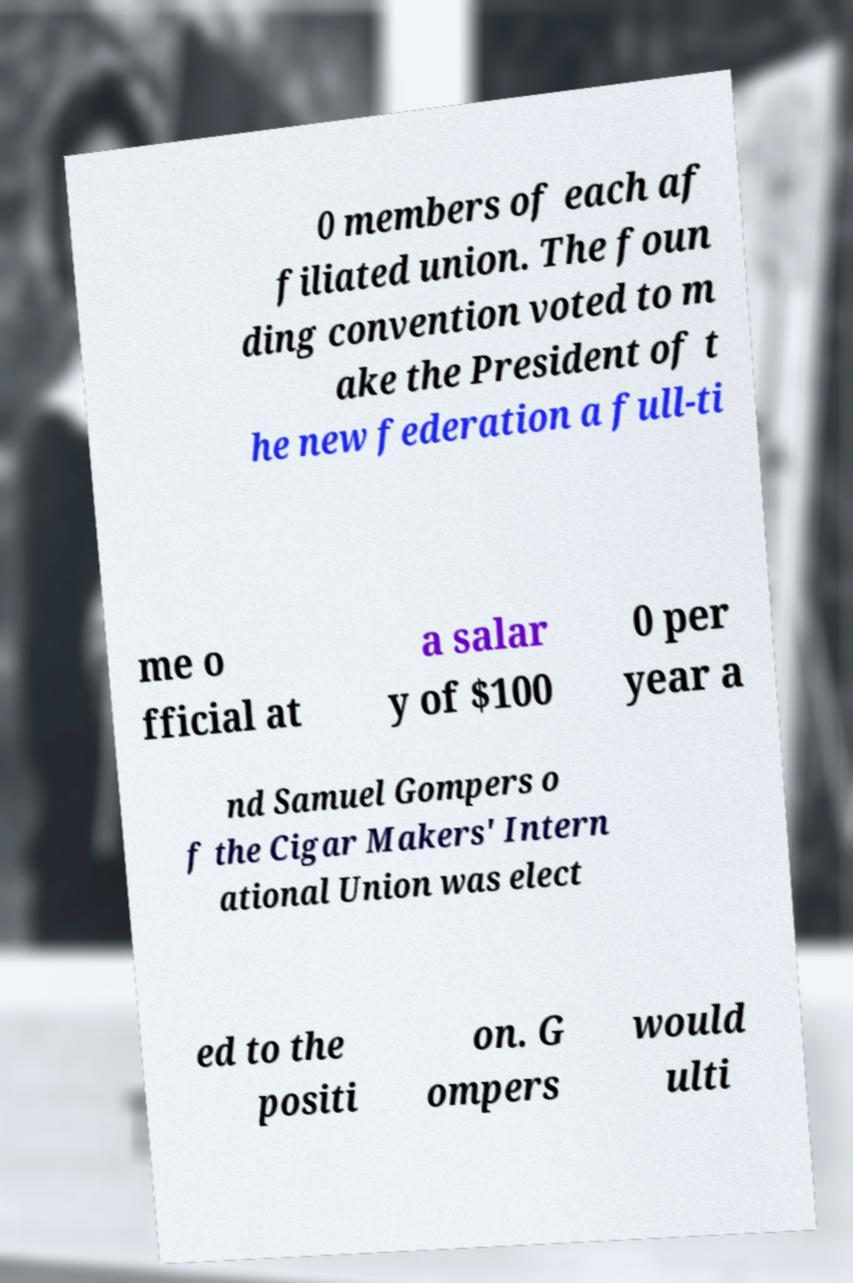Please read and relay the text visible in this image. What does it say? 0 members of each af filiated union. The foun ding convention voted to m ake the President of t he new federation a full-ti me o fficial at a salar y of $100 0 per year a nd Samuel Gompers o f the Cigar Makers' Intern ational Union was elect ed to the positi on. G ompers would ulti 